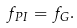Convert formula to latex. <formula><loc_0><loc_0><loc_500><loc_500>f _ { P I } = f _ { G } .</formula> 